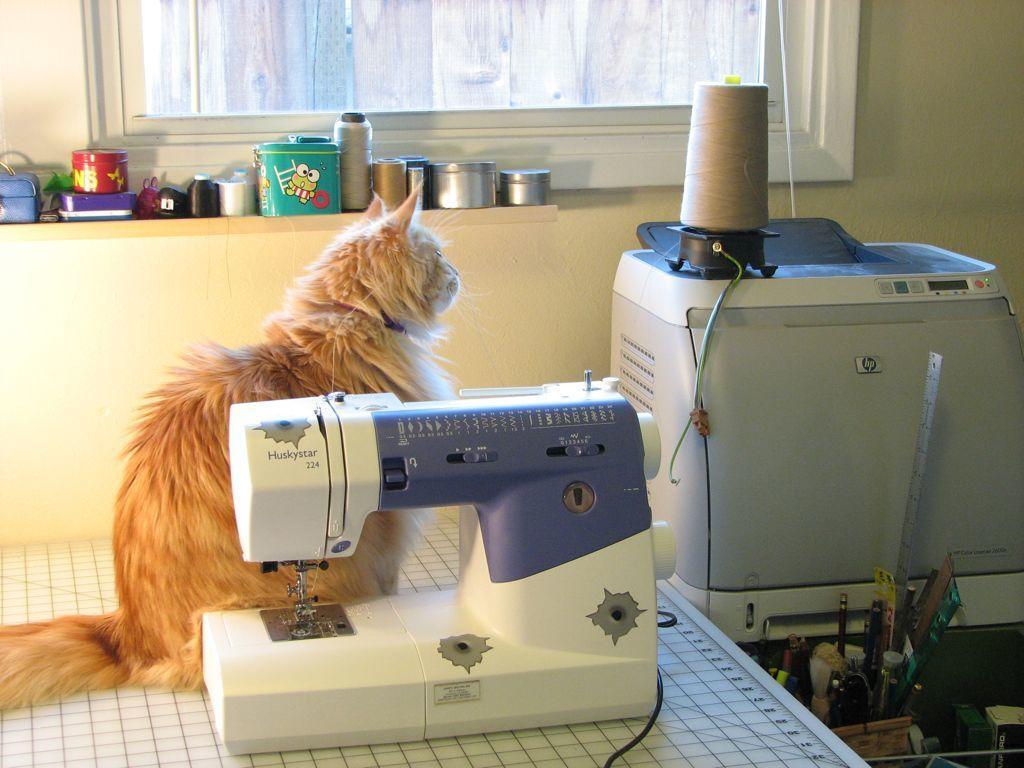How would you summarize this image in a sentence or two? In this image we can see a cat and a sewing machine on the table. To the right side of the image we can see a roll and a machine placed on the surface, group of items placed in a basket. In the background, we can see group of objects on rack, window and the wall. 